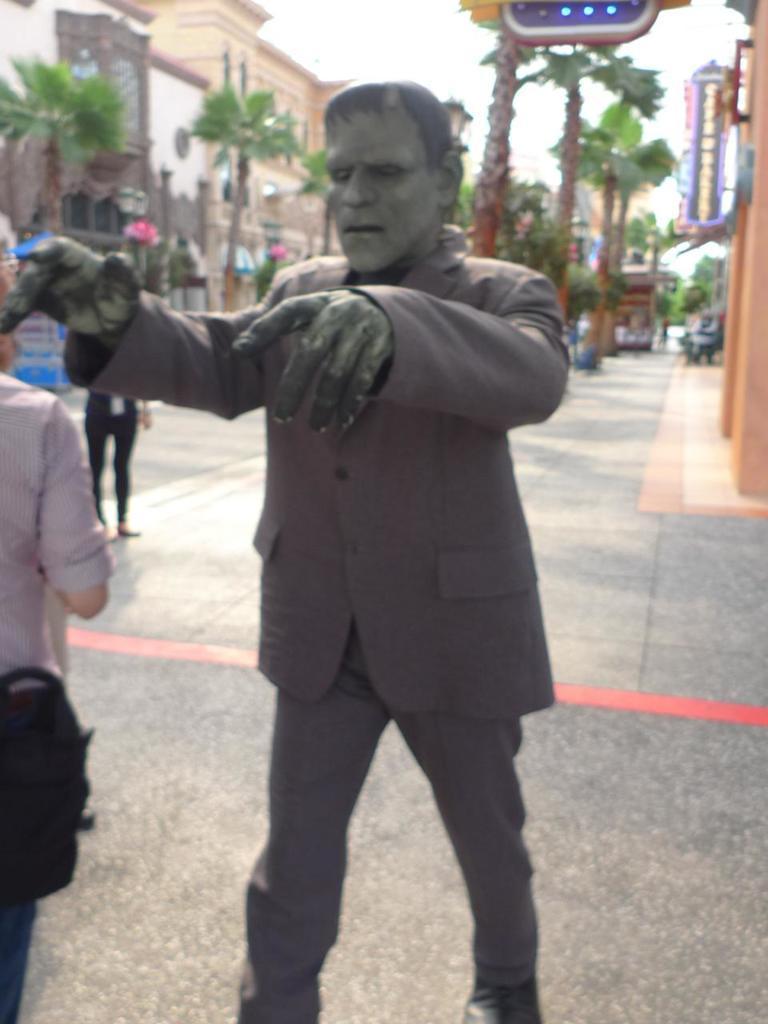Can you describe this image briefly? There is a statue. There are two people. In the back there are trees, buildings and sky. 